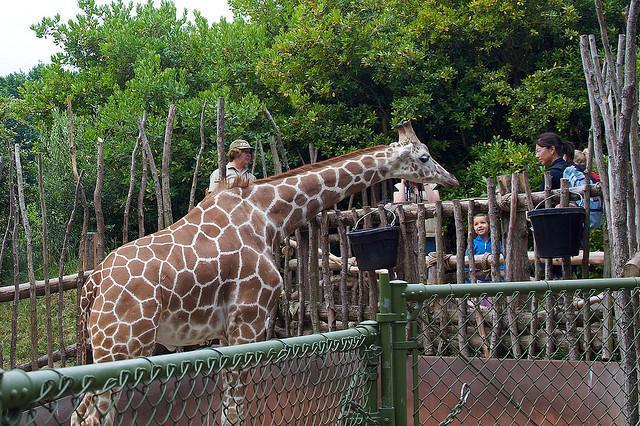How many people are pictured here?
Give a very brief answer. 3. 